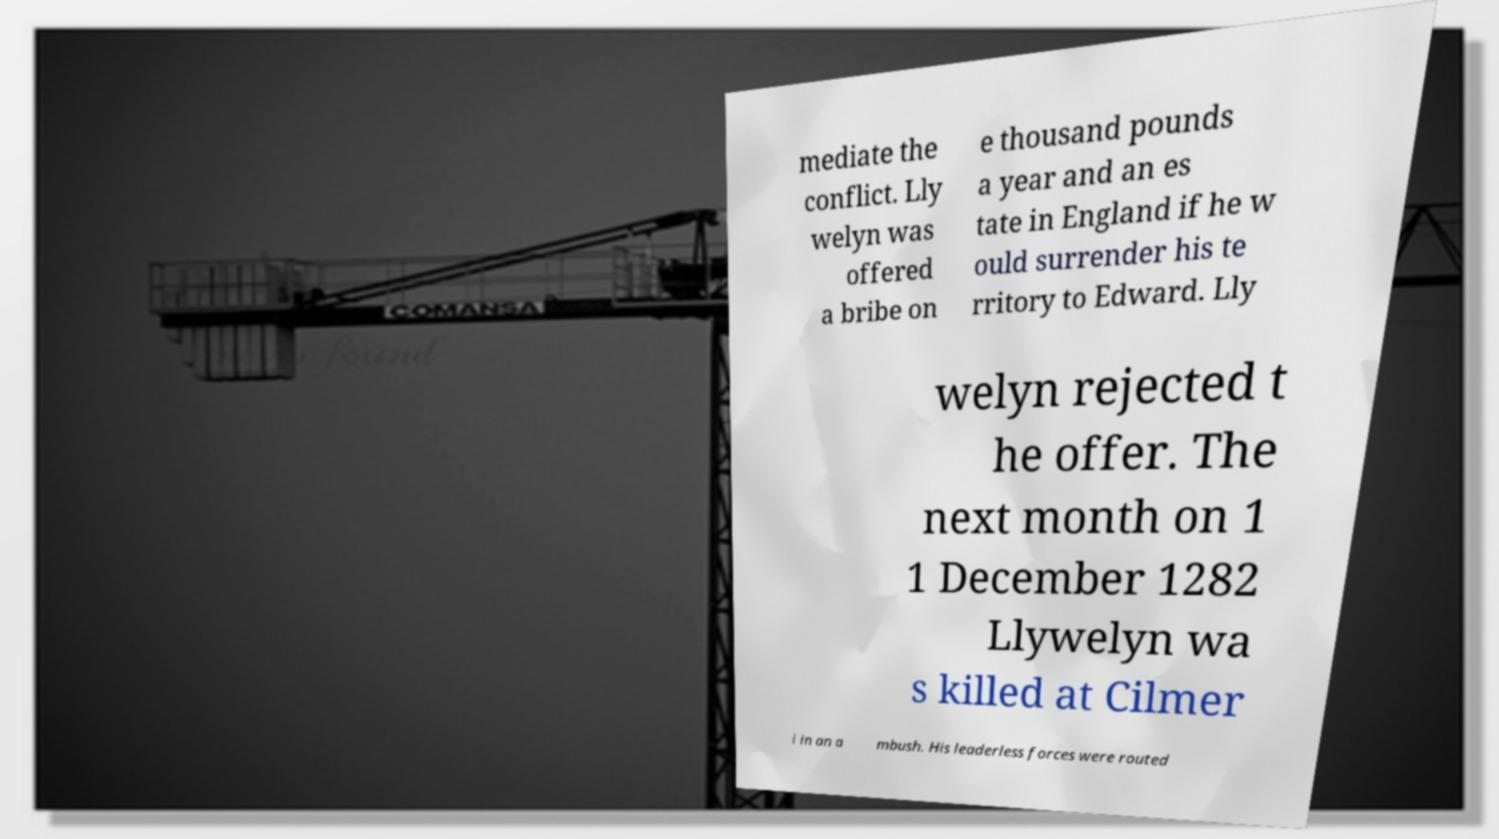Could you assist in decoding the text presented in this image and type it out clearly? mediate the conflict. Lly welyn was offered a bribe on e thousand pounds a year and an es tate in England if he w ould surrender his te rritory to Edward. Lly welyn rejected t he offer. The next month on 1 1 December 1282 Llywelyn wa s killed at Cilmer i in an a mbush. His leaderless forces were routed 